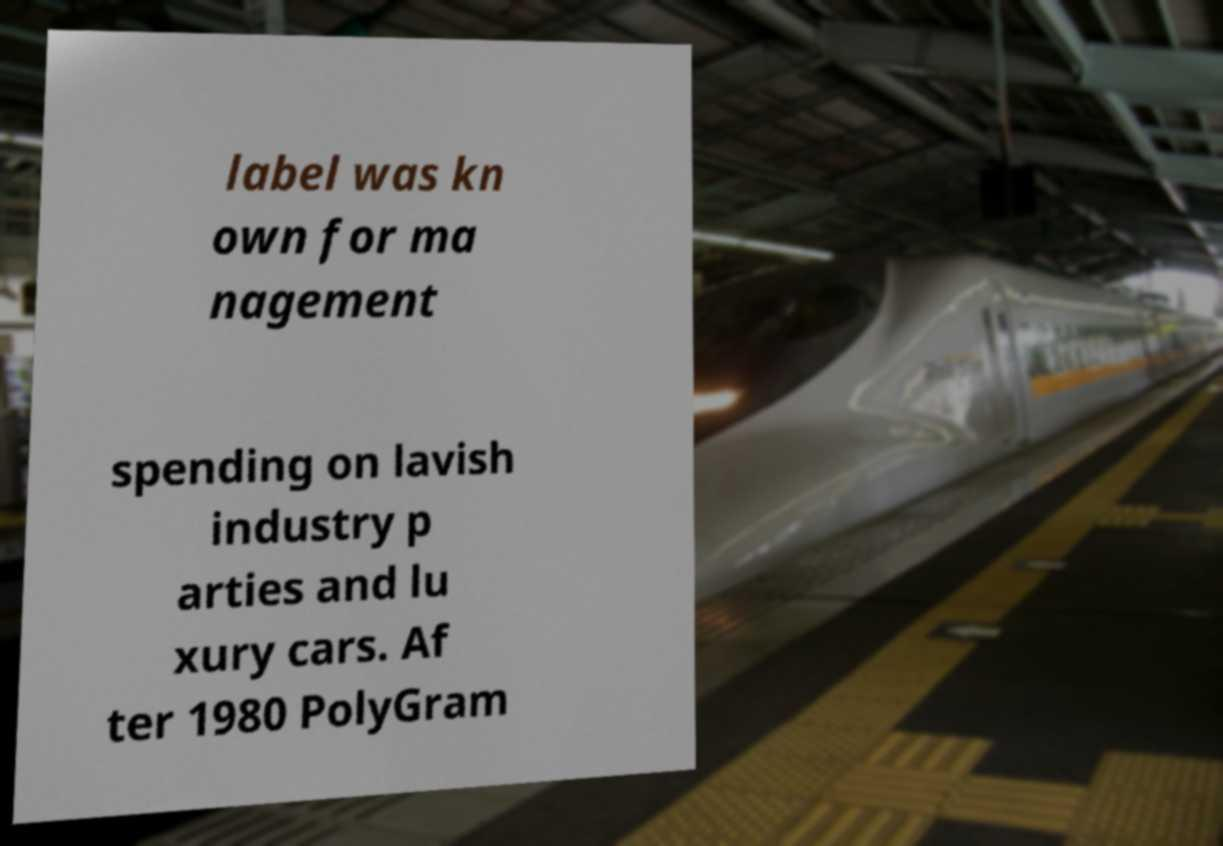For documentation purposes, I need the text within this image transcribed. Could you provide that? label was kn own for ma nagement spending on lavish industry p arties and lu xury cars. Af ter 1980 PolyGram 